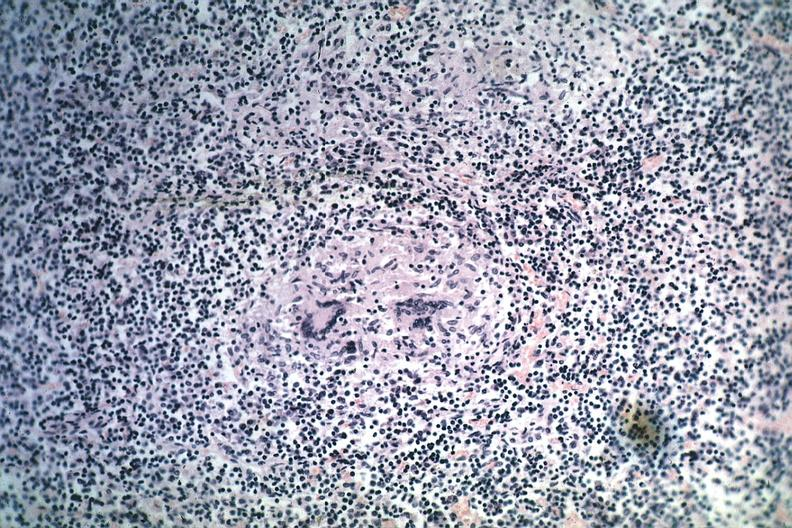what does this image show?
Answer the question using a single word or phrase. Granuloma with minimal necrosis source unknown 